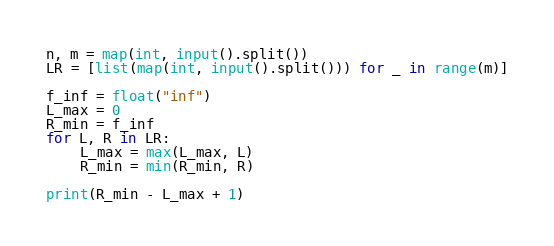Convert code to text. <code><loc_0><loc_0><loc_500><loc_500><_Python_>n, m = map(int, input().split())
LR = [list(map(int, input().split())) for _ in range(m)]

f_inf = float("inf")
L_max = 0
R_min = f_inf
for L, R in LR:
    L_max = max(L_max, L)
    R_min = min(R_min, R)

print(R_min - L_max + 1)
</code> 